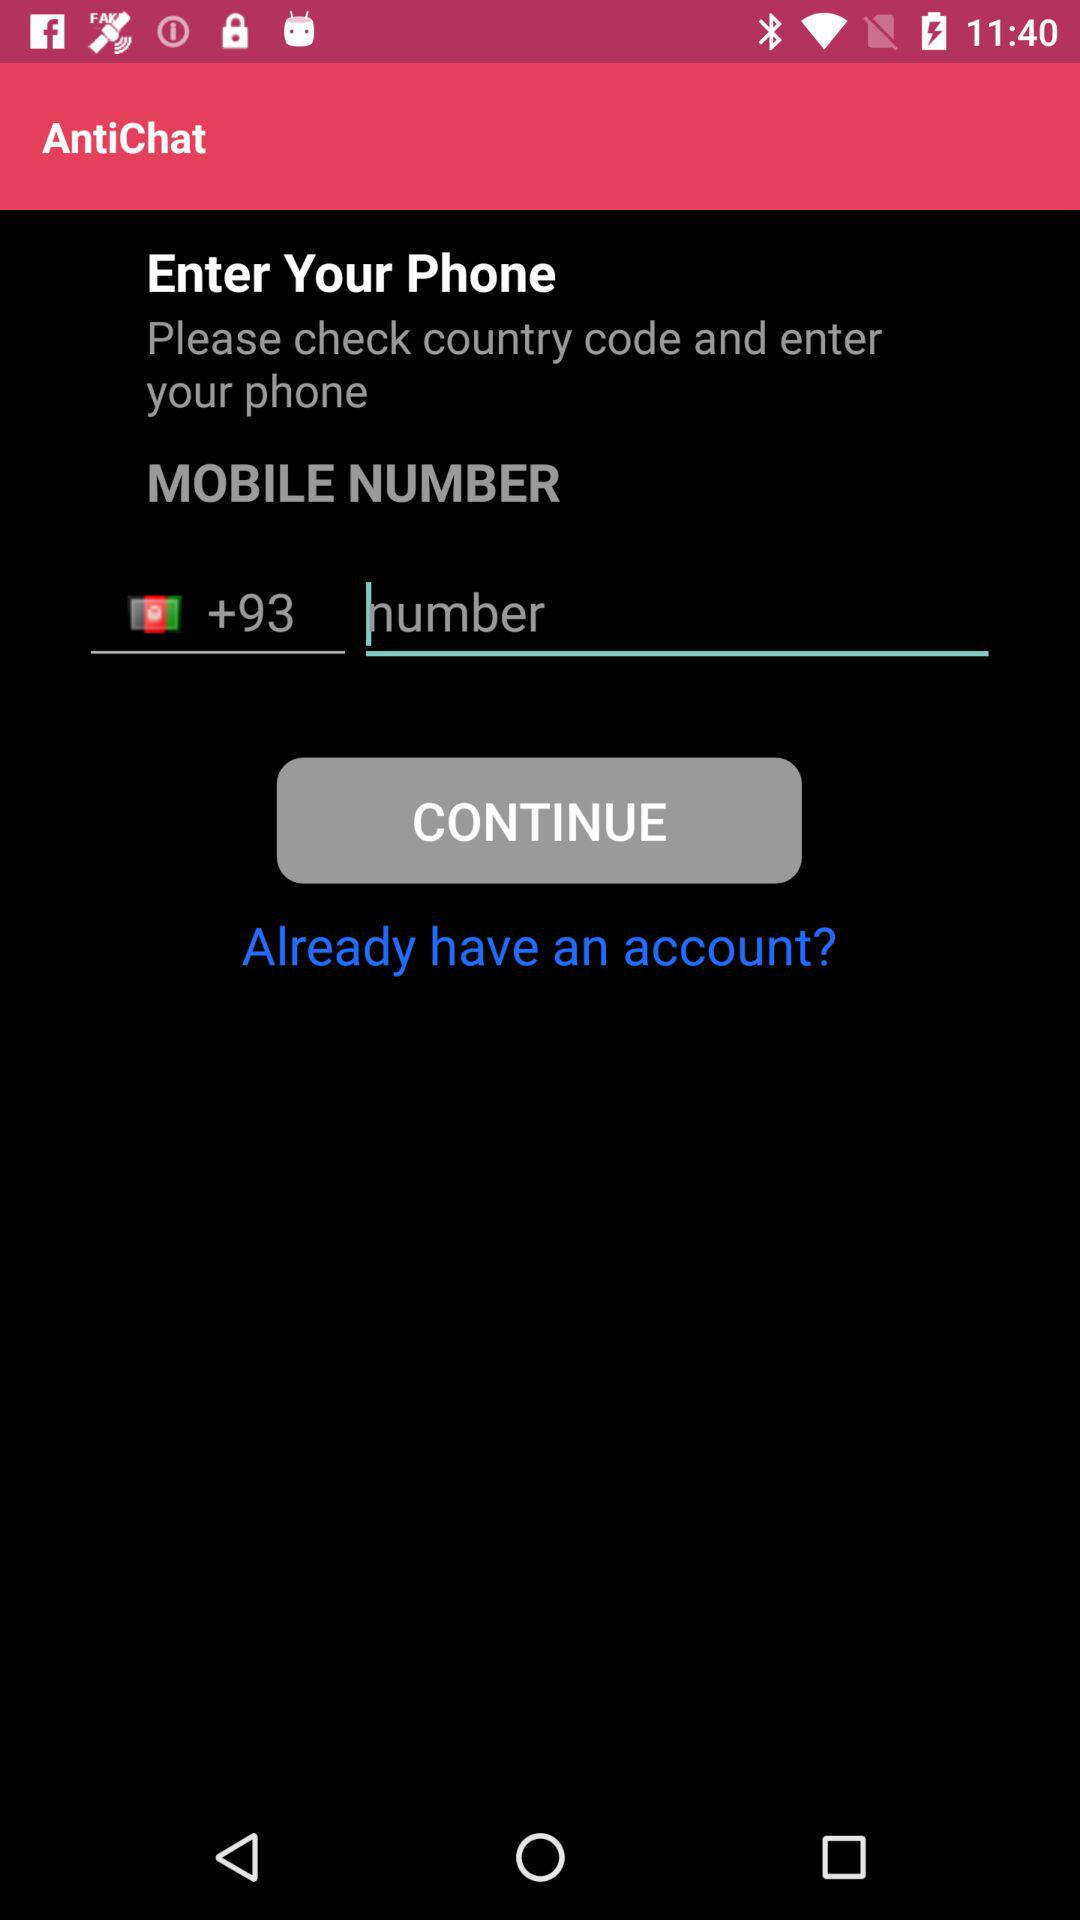What is the name of the application? The application name is "AntiChat". 